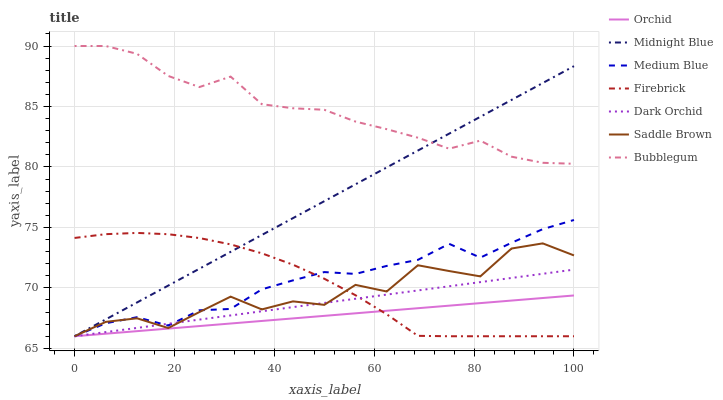Does Orchid have the minimum area under the curve?
Answer yes or no. Yes. Does Bubblegum have the maximum area under the curve?
Answer yes or no. Yes. Does Firebrick have the minimum area under the curve?
Answer yes or no. No. Does Firebrick have the maximum area under the curve?
Answer yes or no. No. Is Midnight Blue the smoothest?
Answer yes or no. Yes. Is Saddle Brown the roughest?
Answer yes or no. Yes. Is Firebrick the smoothest?
Answer yes or no. No. Is Firebrick the roughest?
Answer yes or no. No. Does Midnight Blue have the lowest value?
Answer yes or no. Yes. Does Bubblegum have the lowest value?
Answer yes or no. No. Does Bubblegum have the highest value?
Answer yes or no. Yes. Does Firebrick have the highest value?
Answer yes or no. No. Is Medium Blue less than Bubblegum?
Answer yes or no. Yes. Is Bubblegum greater than Orchid?
Answer yes or no. Yes. Does Firebrick intersect Orchid?
Answer yes or no. Yes. Is Firebrick less than Orchid?
Answer yes or no. No. Is Firebrick greater than Orchid?
Answer yes or no. No. Does Medium Blue intersect Bubblegum?
Answer yes or no. No. 